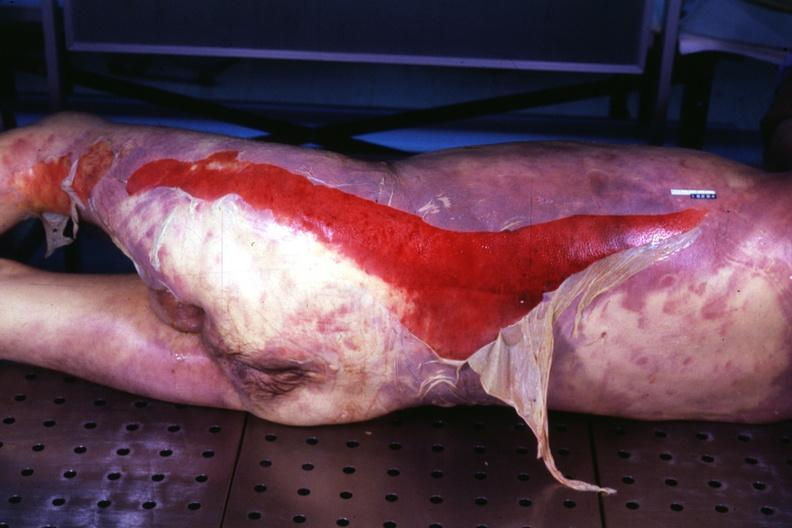where is this?
Answer the question using a single word or phrase. Skin 